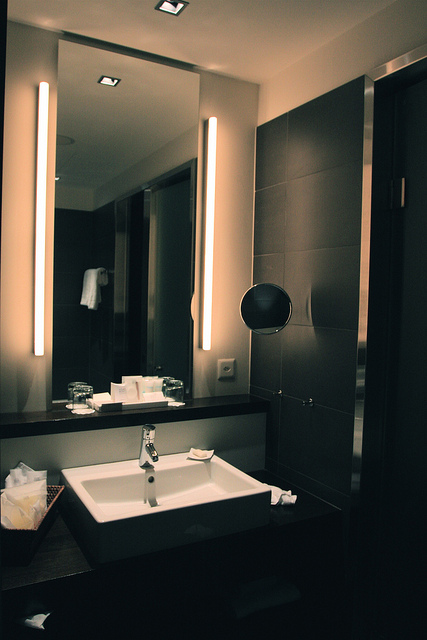How many lightbulbs can be seen in the image? The image shows three illuminated lightbulbs, providing ample lighting to the room. 